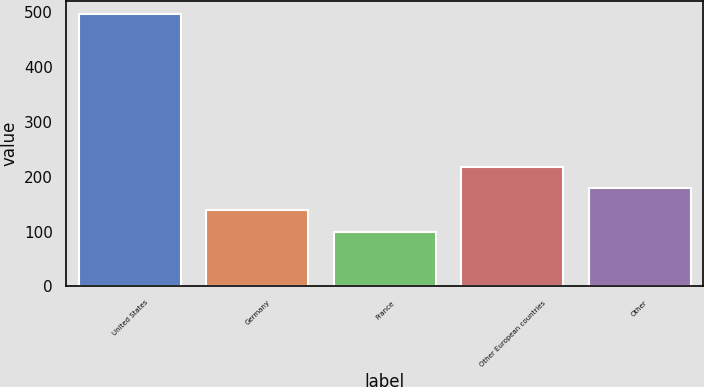Convert chart to OTSL. <chart><loc_0><loc_0><loc_500><loc_500><bar_chart><fcel>United States<fcel>Germany<fcel>France<fcel>Other European countries<fcel>Other<nl><fcel>496.4<fcel>139.46<fcel>99.8<fcel>218.78<fcel>179.12<nl></chart> 